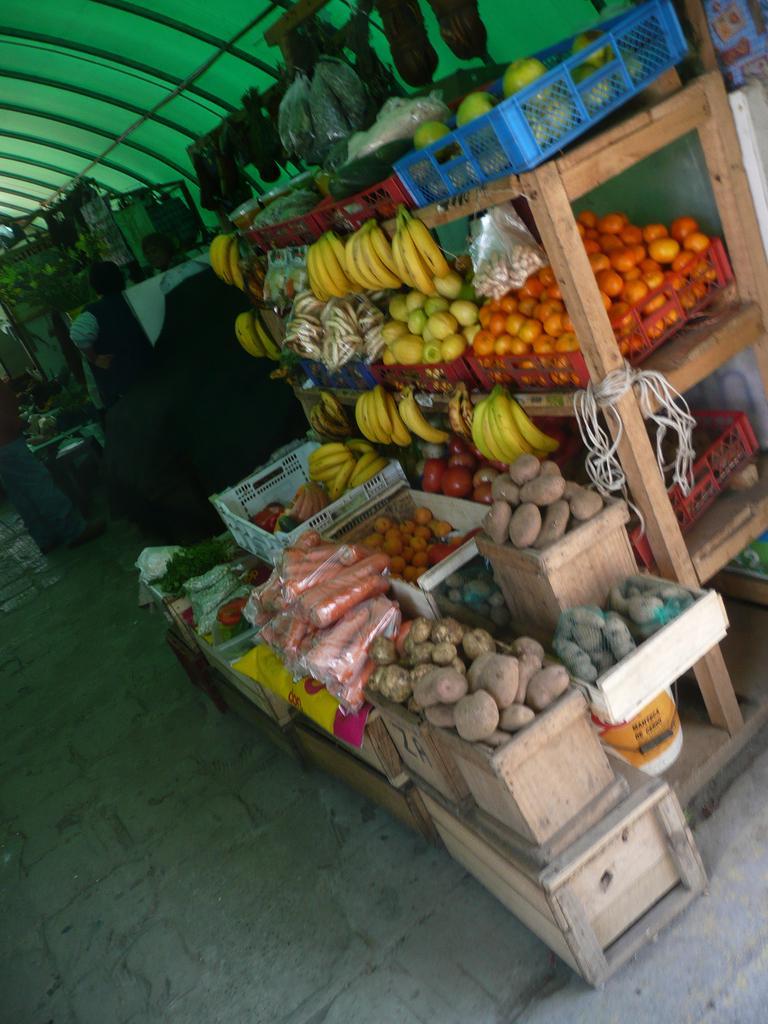In one or two sentences, can you explain what this image depicts? In this image we can see a group of fruits and vegetables containing bananas, oranges, carrots, potatoes, tomatoes and leafy vegetables placed in the containers and the racks under a roof. On the backside we can see a group of people standing. 